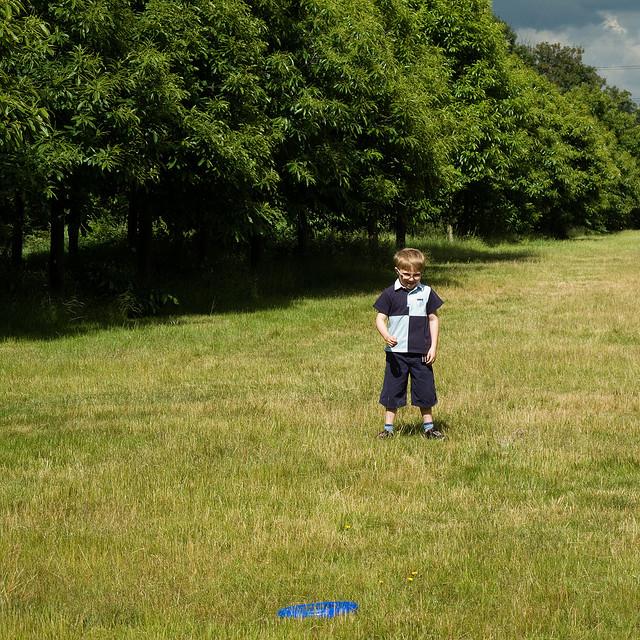Are they having a summer party?
Short answer required. No. What is the child looking for?
Short answer required. Frisbee. Are people having fun?
Be succinct. Yes. What is casting the shadows on the grass to the left of the photo?
Short answer required. Trees. Is the boy in the photograph wearing a baseball cap?
Answer briefly. No. Where is sun protection?
Concise answer only. Skin. Do the clouds in the upper right corner appear heavy with precipitation?
Give a very brief answer. Yes. What is the child throwing?
Answer briefly. Frisbee. 